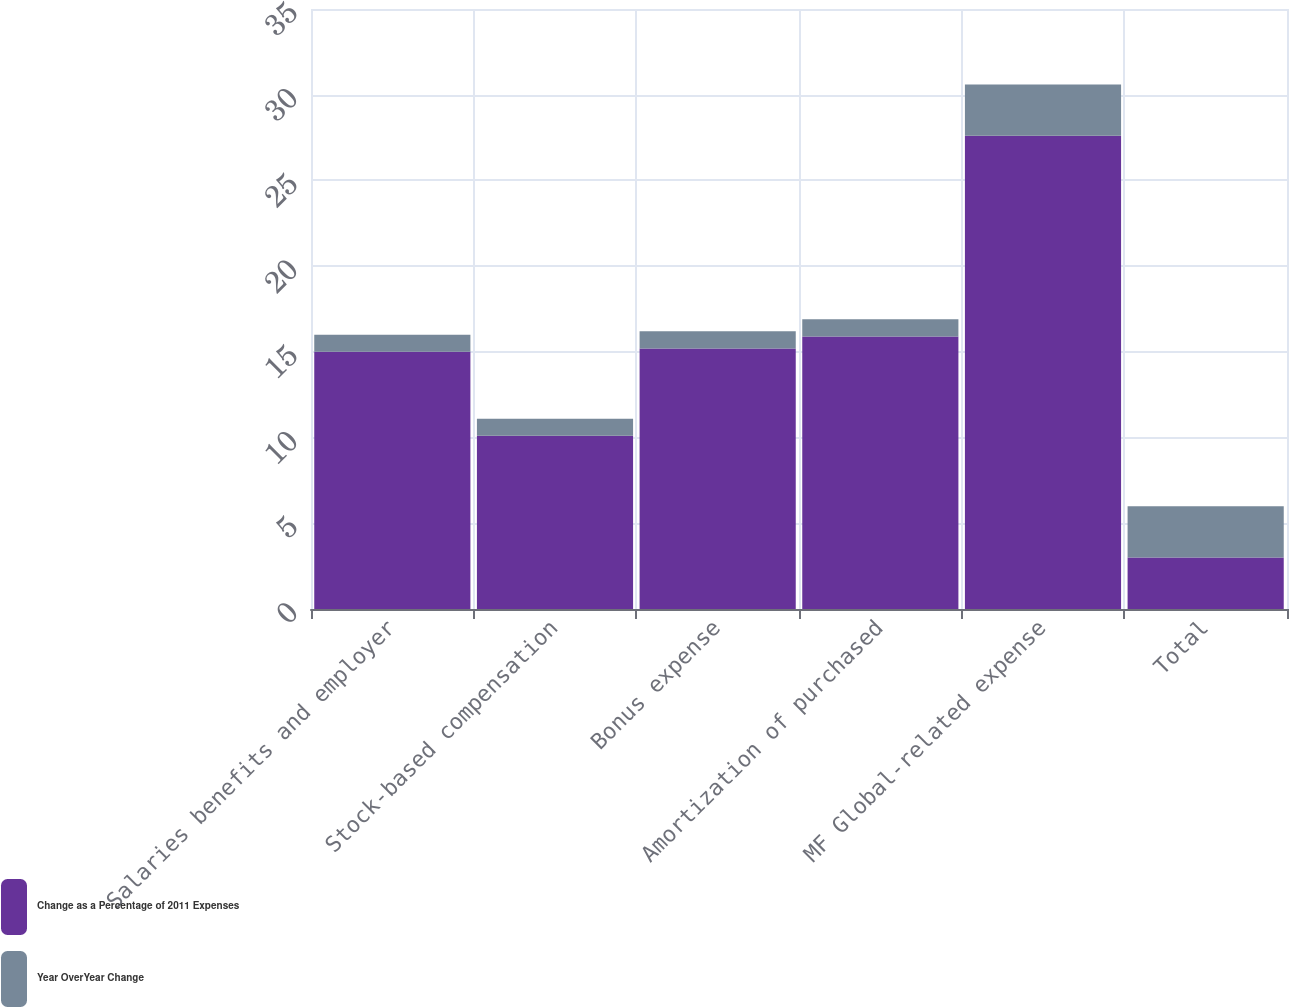<chart> <loc_0><loc_0><loc_500><loc_500><stacked_bar_chart><ecel><fcel>Salaries benefits and employer<fcel>Stock-based compensation<fcel>Bonus expense<fcel>Amortization of purchased<fcel>MF Global-related expense<fcel>Total<nl><fcel>Change as a Percentage of 2011 Expenses<fcel>15<fcel>10.1<fcel>15.2<fcel>15.9<fcel>27.6<fcel>3<nl><fcel>Year OverYear Change<fcel>1<fcel>1<fcel>1<fcel>1<fcel>3<fcel>3<nl></chart> 